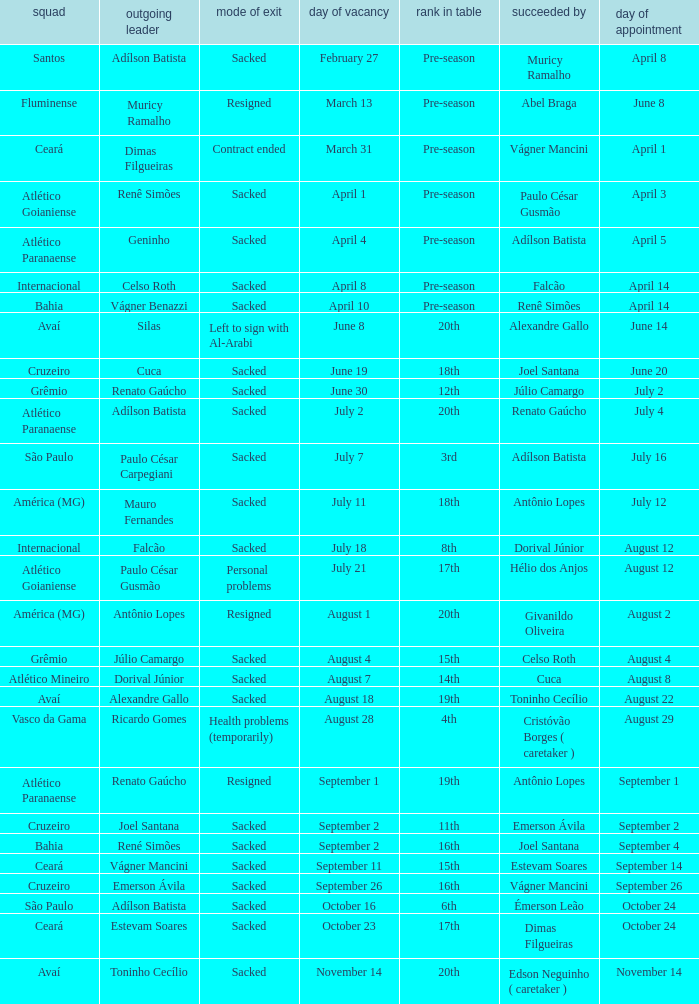Who was the new Santos manager? Muricy Ramalho. 